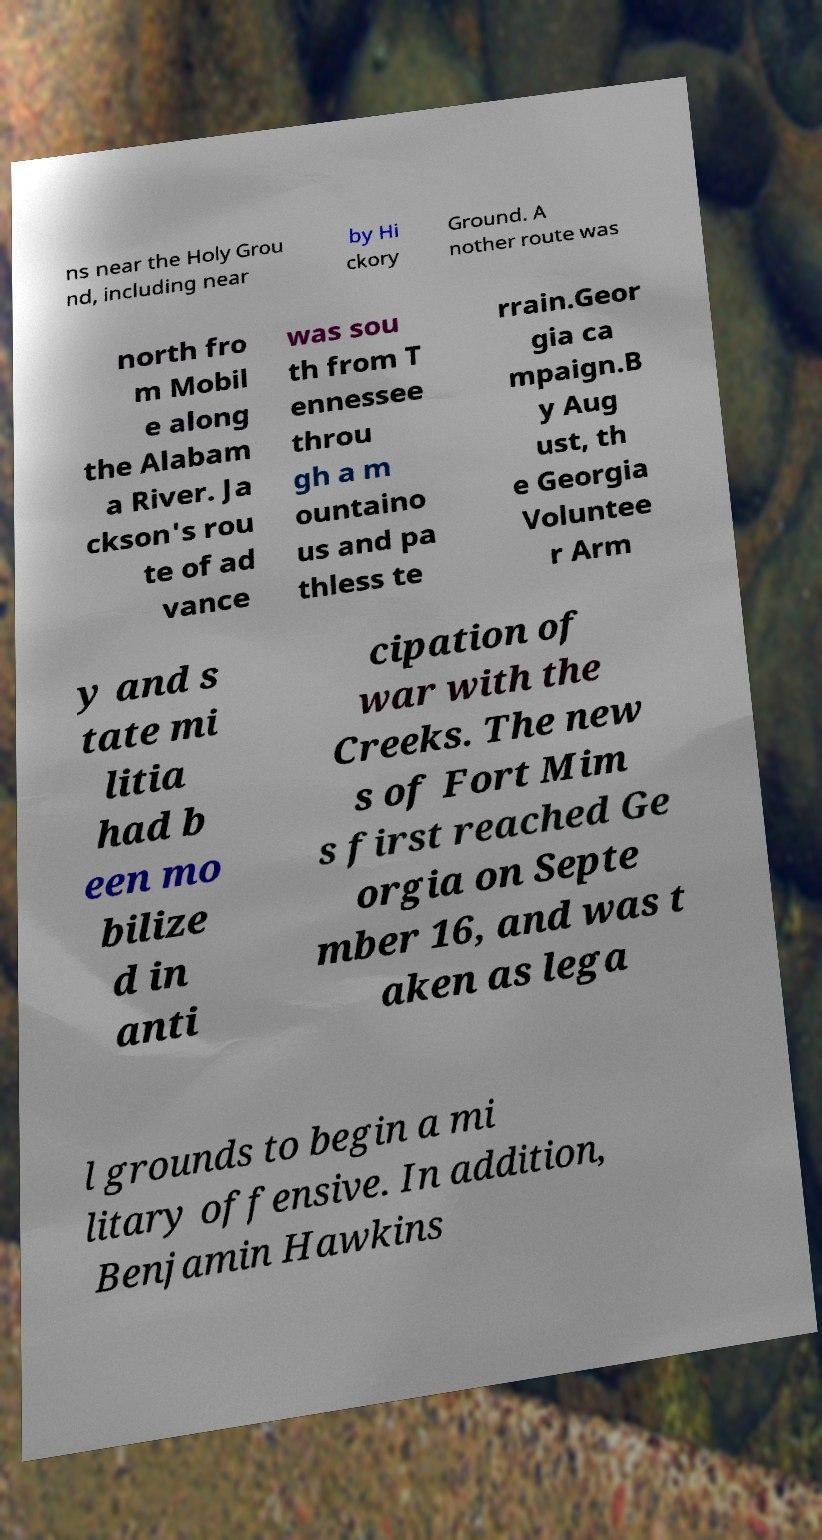What messages or text are displayed in this image? I need them in a readable, typed format. ns near the Holy Grou nd, including near by Hi ckory Ground. A nother route was north fro m Mobil e along the Alabam a River. Ja ckson's rou te of ad vance was sou th from T ennessee throu gh a m ountaino us and pa thless te rrain.Geor gia ca mpaign.B y Aug ust, th e Georgia Voluntee r Arm y and s tate mi litia had b een mo bilize d in anti cipation of war with the Creeks. The new s of Fort Mim s first reached Ge orgia on Septe mber 16, and was t aken as lega l grounds to begin a mi litary offensive. In addition, Benjamin Hawkins 